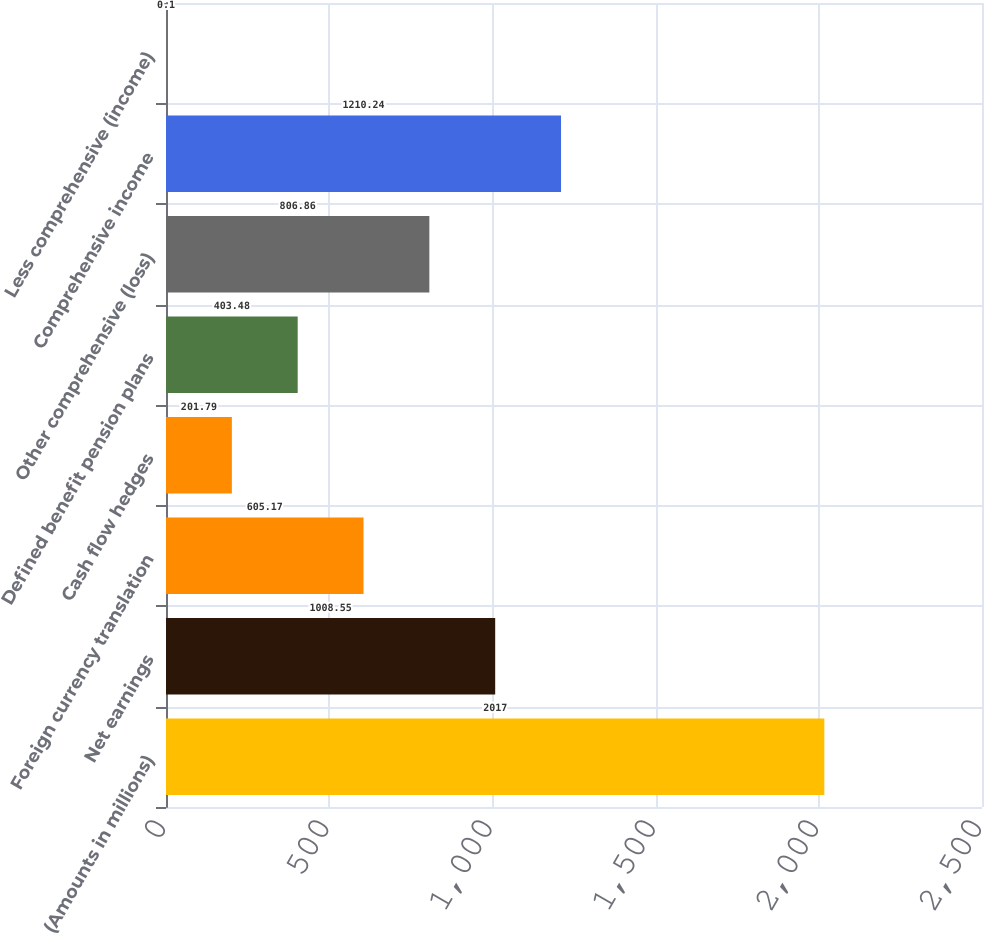Convert chart to OTSL. <chart><loc_0><loc_0><loc_500><loc_500><bar_chart><fcel>(Amounts in millions)<fcel>Net earnings<fcel>Foreign currency translation<fcel>Cash flow hedges<fcel>Defined benefit pension plans<fcel>Other comprehensive (loss)<fcel>Comprehensive income<fcel>Less comprehensive (income)<nl><fcel>2017<fcel>1008.55<fcel>605.17<fcel>201.79<fcel>403.48<fcel>806.86<fcel>1210.24<fcel>0.1<nl></chart> 